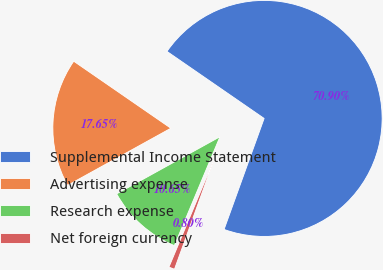Convert chart to OTSL. <chart><loc_0><loc_0><loc_500><loc_500><pie_chart><fcel>Supplemental Income Statement<fcel>Advertising expense<fcel>Research expense<fcel>Net foreign currency<nl><fcel>70.9%<fcel>17.65%<fcel>10.65%<fcel>0.8%<nl></chart> 